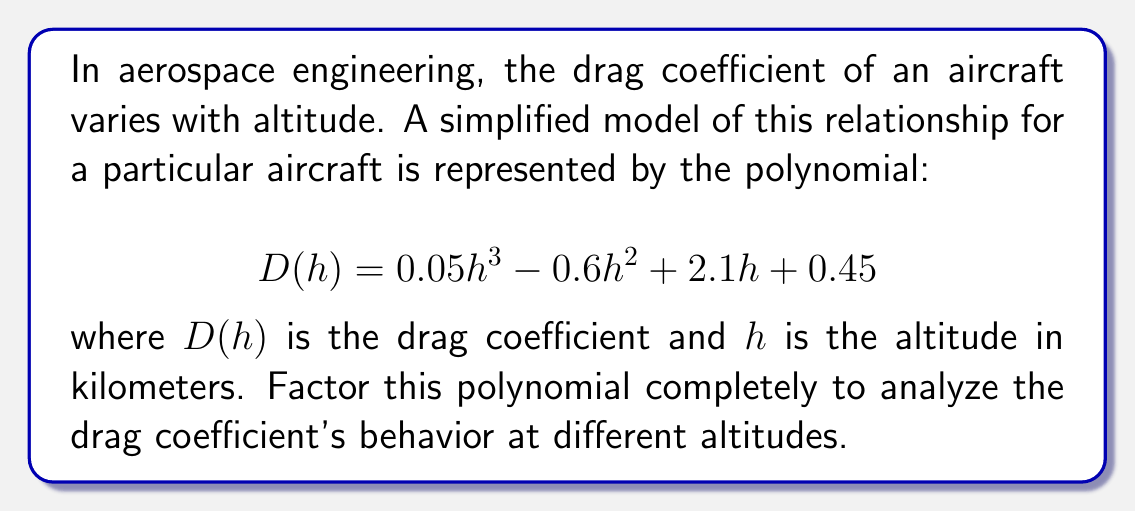What is the answer to this math problem? Let's factor this polynomial step-by-step:

1) First, we need to check if there's a common factor:
   $$ 0.05h^3 - 0.6h^2 + 2.1h + 0.45 $$
   There's no common factor for all terms.

2) Next, let's check if it's a perfect cube or has any other obvious factorization. It doesn't appear to be a perfect cube or have any obvious factorization.

3) Let's try to find a root. We can use the rational root theorem. The possible rational roots are the factors of the constant term (0.45) divided by the factors of the leading coefficient (0.05):
   $\pm 1, \pm 3, \pm 5, \pm 9, \pm 0.15, \pm 0.45, \pm 0.75, \pm 1.35, \pm 2.25, \pm 4.5$

4) Testing these values, we find that $h = 0.3$ is a root.

5) We can factor out $(h - 0.3)$:
   $$ 0.05h^3 - 0.6h^2 + 2.1h + 0.45 = (h - 0.3)(0.05h^2 - 0.45h + 1.5) $$

6) The quadratic factor $0.05h^2 - 0.45h + 1.5$ can be further factored:
   $$ 0.05(h^2 - 9h + 30) = 0.05(h - 3)(h - 6) $$

7) Therefore, the complete factorization is:
   $$ D(h) = 0.05(h - 0.3)(h - 3)(h - 6) $$

This factorization shows that the drag coefficient will be zero at altitudes of 0.3 km, 3 km, and 6 km, which could represent critical points in the aircraft's performance at different altitudes.
Answer: $$ D(h) = 0.05(h - 0.3)(h - 3)(h - 6) $$ 